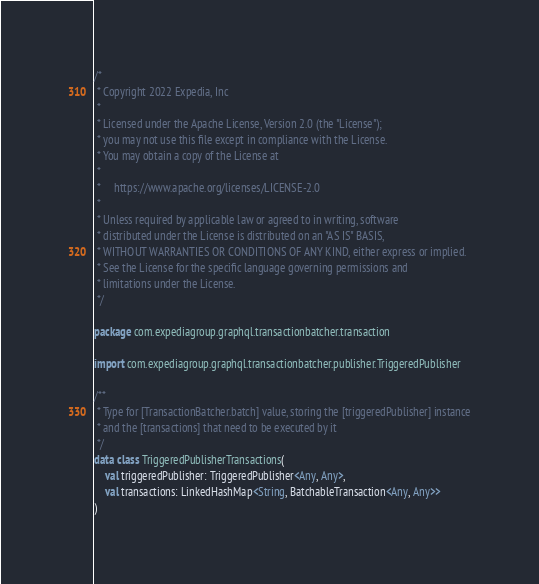<code> <loc_0><loc_0><loc_500><loc_500><_Kotlin_>/*
 * Copyright 2022 Expedia, Inc
 *
 * Licensed under the Apache License, Version 2.0 (the "License");
 * you may not use this file except in compliance with the License.
 * You may obtain a copy of the License at
 *
 *     https://www.apache.org/licenses/LICENSE-2.0
 *
 * Unless required by applicable law or agreed to in writing, software
 * distributed under the License is distributed on an "AS IS" BASIS,
 * WITHOUT WARRANTIES OR CONDITIONS OF ANY KIND, either express or implied.
 * See the License for the specific language governing permissions and
 * limitations under the License.
 */

package com.expediagroup.graphql.transactionbatcher.transaction

import com.expediagroup.graphql.transactionbatcher.publisher.TriggeredPublisher

/**
 * Type for [TransactionBatcher.batch] value, storing the [triggeredPublisher] instance
 * and the [transactions] that need to be executed by it
 */
data class TriggeredPublisherTransactions(
    val triggeredPublisher: TriggeredPublisher<Any, Any>,
    val transactions: LinkedHashMap<String, BatchableTransaction<Any, Any>>
)
</code> 